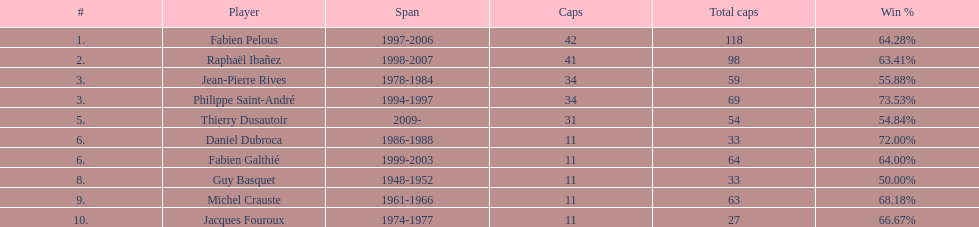How many captains played 11 capped matches? 5. 